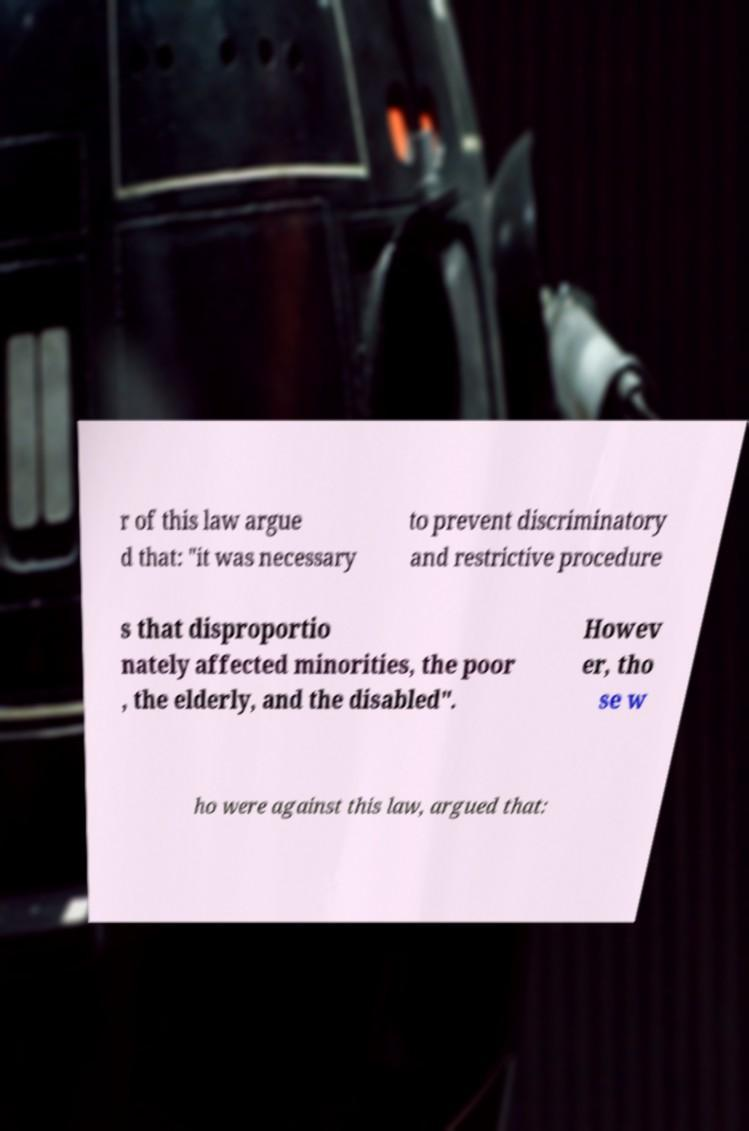There's text embedded in this image that I need extracted. Can you transcribe it verbatim? r of this law argue d that: "it was necessary to prevent discriminatory and restrictive procedure s that disproportio nately affected minorities, the poor , the elderly, and the disabled". Howev er, tho se w ho were against this law, argued that: 